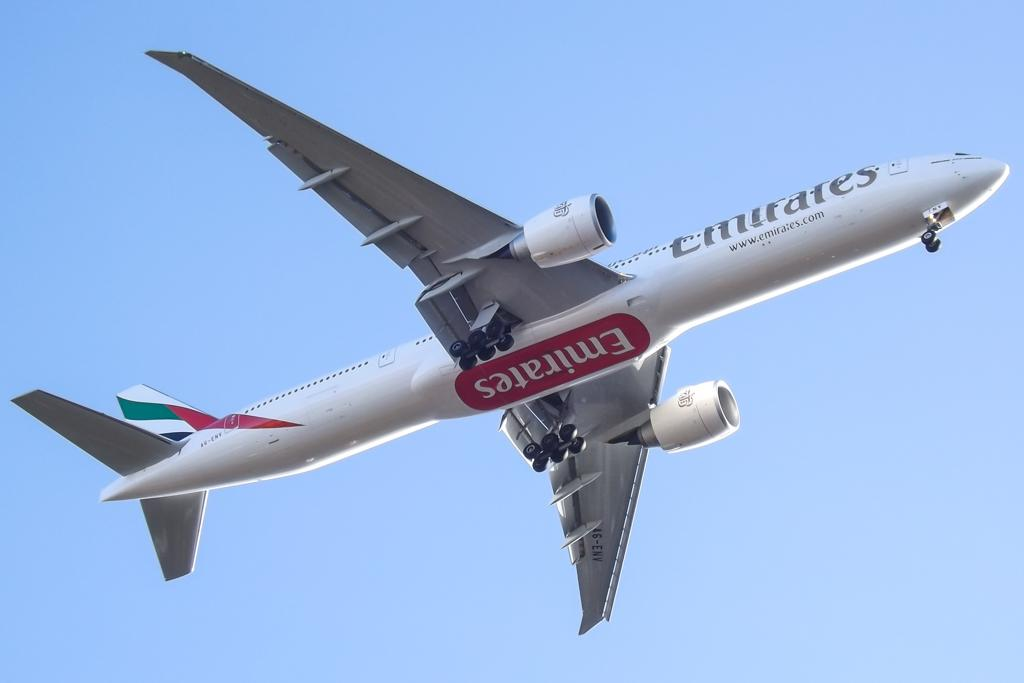What is the main subject of the image? The main subject of the image is an airplane. What can be seen in the background of the image? The background of the image is blue. How many cakes are displayed on the badge in the image? There is no badge or cake present in the image; it features an airplane with a blue background. 